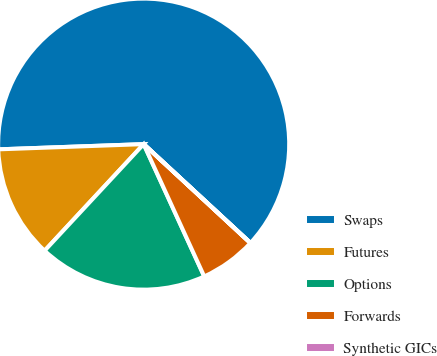Convert chart to OTSL. <chart><loc_0><loc_0><loc_500><loc_500><pie_chart><fcel>Swaps<fcel>Futures<fcel>Options<fcel>Forwards<fcel>Synthetic GICs<nl><fcel>62.45%<fcel>12.51%<fcel>18.75%<fcel>6.27%<fcel>0.02%<nl></chart> 